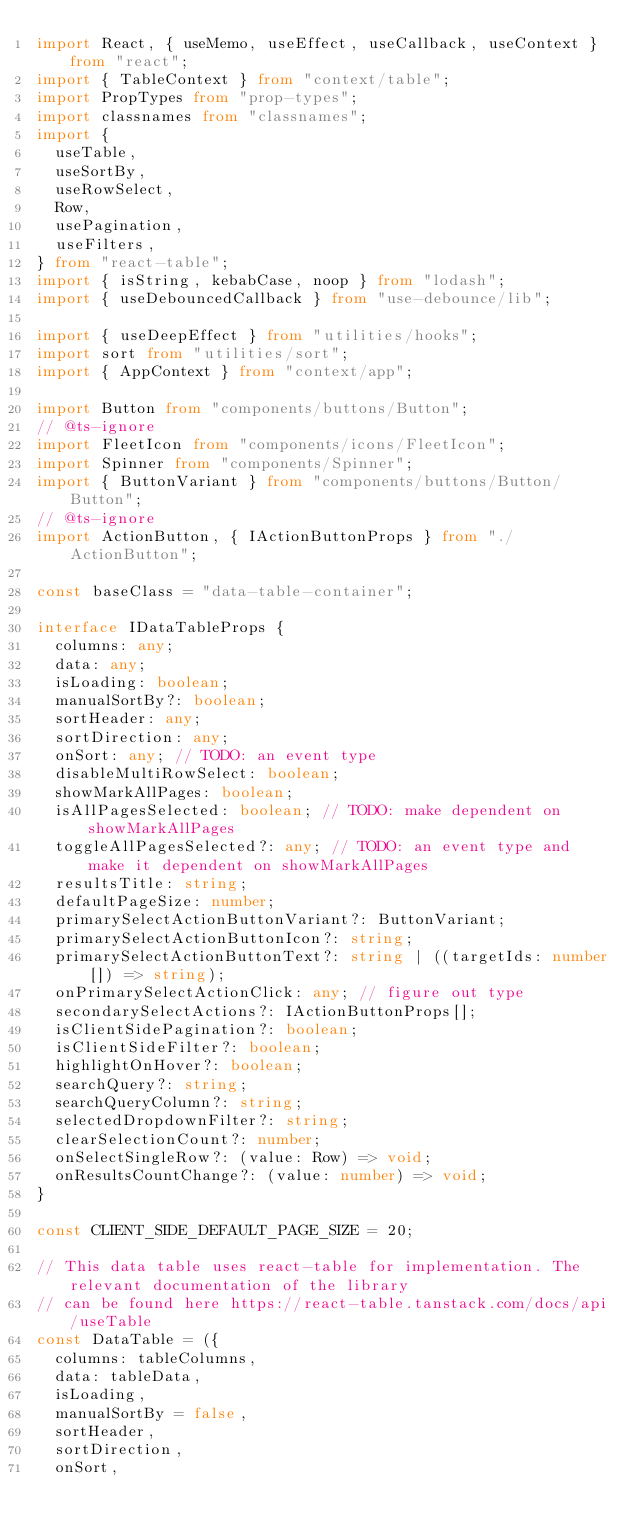Convert code to text. <code><loc_0><loc_0><loc_500><loc_500><_TypeScript_>import React, { useMemo, useEffect, useCallback, useContext } from "react";
import { TableContext } from "context/table";
import PropTypes from "prop-types";
import classnames from "classnames";
import {
  useTable,
  useSortBy,
  useRowSelect,
  Row,
  usePagination,
  useFilters,
} from "react-table";
import { isString, kebabCase, noop } from "lodash";
import { useDebouncedCallback } from "use-debounce/lib";

import { useDeepEffect } from "utilities/hooks";
import sort from "utilities/sort";
import { AppContext } from "context/app";

import Button from "components/buttons/Button";
// @ts-ignore
import FleetIcon from "components/icons/FleetIcon";
import Spinner from "components/Spinner";
import { ButtonVariant } from "components/buttons/Button/Button";
// @ts-ignore
import ActionButton, { IActionButtonProps } from "./ActionButton";

const baseClass = "data-table-container";

interface IDataTableProps {
  columns: any;
  data: any;
  isLoading: boolean;
  manualSortBy?: boolean;
  sortHeader: any;
  sortDirection: any;
  onSort: any; // TODO: an event type
  disableMultiRowSelect: boolean;
  showMarkAllPages: boolean;
  isAllPagesSelected: boolean; // TODO: make dependent on showMarkAllPages
  toggleAllPagesSelected?: any; // TODO: an event type and make it dependent on showMarkAllPages
  resultsTitle: string;
  defaultPageSize: number;
  primarySelectActionButtonVariant?: ButtonVariant;
  primarySelectActionButtonIcon?: string;
  primarySelectActionButtonText?: string | ((targetIds: number[]) => string);
  onPrimarySelectActionClick: any; // figure out type
  secondarySelectActions?: IActionButtonProps[];
  isClientSidePagination?: boolean;
  isClientSideFilter?: boolean;
  highlightOnHover?: boolean;
  searchQuery?: string;
  searchQueryColumn?: string;
  selectedDropdownFilter?: string;
  clearSelectionCount?: number;
  onSelectSingleRow?: (value: Row) => void;
  onResultsCountChange?: (value: number) => void;
}

const CLIENT_SIDE_DEFAULT_PAGE_SIZE = 20;

// This data table uses react-table for implementation. The relevant documentation of the library
// can be found here https://react-table.tanstack.com/docs/api/useTable
const DataTable = ({
  columns: tableColumns,
  data: tableData,
  isLoading,
  manualSortBy = false,
  sortHeader,
  sortDirection,
  onSort,</code> 